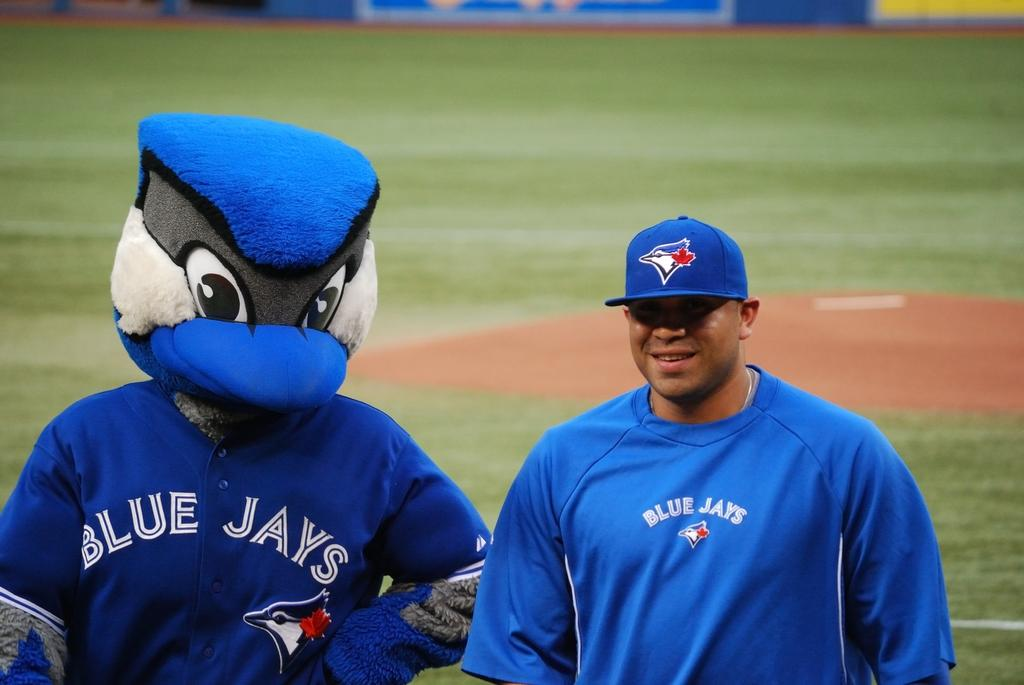<image>
Relay a brief, clear account of the picture shown. Blue Jays mascot and baseball player wearing blue uniforms 